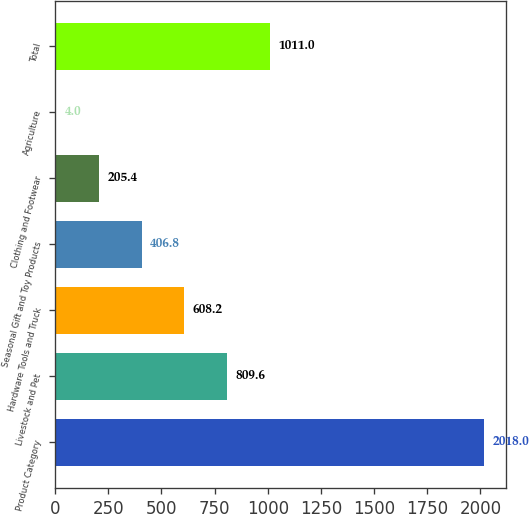Convert chart to OTSL. <chart><loc_0><loc_0><loc_500><loc_500><bar_chart><fcel>Product Category<fcel>Livestock and Pet<fcel>Hardware Tools and Truck<fcel>Seasonal Gift and Toy Products<fcel>Clothing and Footwear<fcel>Agriculture<fcel>Total<nl><fcel>2018<fcel>809.6<fcel>608.2<fcel>406.8<fcel>205.4<fcel>4<fcel>1011<nl></chart> 